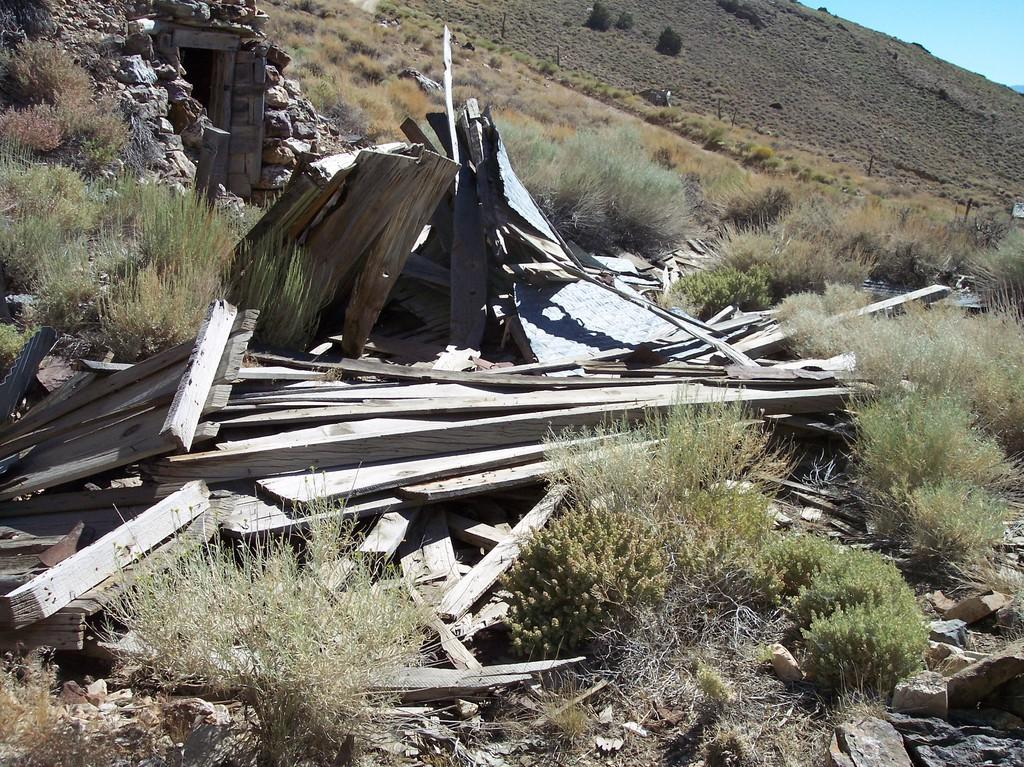What type of environment is depicted in the image? The image is an outside view. What materials can be seen in the image? There are wood materials in the image. What type of vegetation is present in the image? There are plants in the image. What is on the ground in the image? There are rocks on the ground in the image. What part of the natural environment is visible in the image? The sky is visible in the top right corner of the image. What type of credit card is shown in the image? There is no credit card present in the image. How much beef is visible in the image? There is no beef present in the image. 